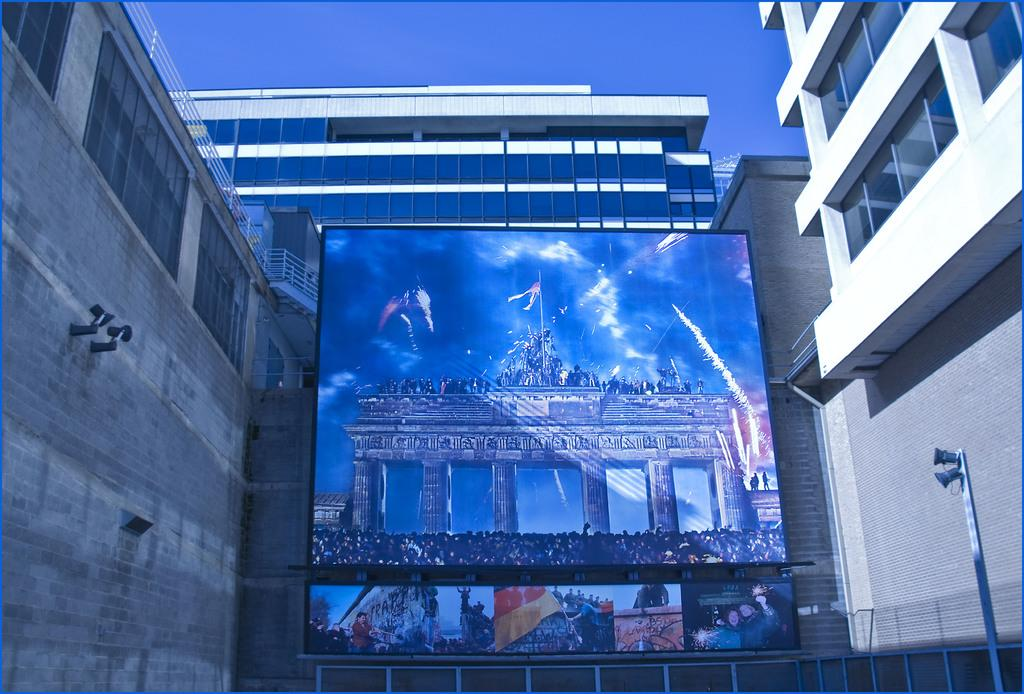Who or what is present in the image? There is a person in the image. Where is the person located in relation to the buildings? The person is between buildings. What can be seen in the bottom right of the image? There is a pole in the bottom right of the image. What type of structure is visible in the image? There is a building visible in the image. What is visible at the top of the image? The sky is visible at the top of the image. What type of tin is the person holding in the image? There is no tin present in the image. How does the person's stomach appear in the image? The image does not provide enough detail to describe the person's stomach. 